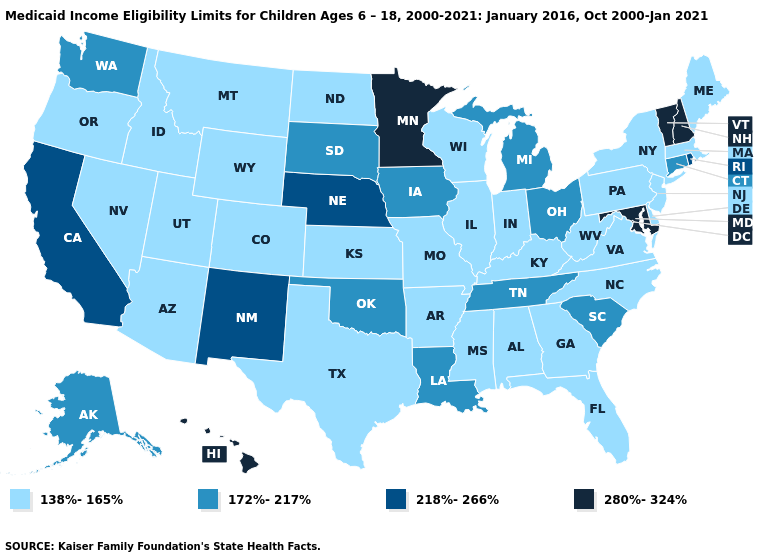Does Michigan have the same value as Vermont?
Answer briefly. No. Name the states that have a value in the range 280%-324%?
Concise answer only. Hawaii, Maryland, Minnesota, New Hampshire, Vermont. Among the states that border New Jersey , which have the lowest value?
Answer briefly. Delaware, New York, Pennsylvania. What is the value of Tennessee?
Quick response, please. 172%-217%. Among the states that border Connecticut , which have the highest value?
Concise answer only. Rhode Island. What is the highest value in states that border New Hampshire?
Answer briefly. 280%-324%. What is the value of West Virginia?
Keep it brief. 138%-165%. What is the value of Pennsylvania?
Answer briefly. 138%-165%. Name the states that have a value in the range 172%-217%?
Write a very short answer. Alaska, Connecticut, Iowa, Louisiana, Michigan, Ohio, Oklahoma, South Carolina, South Dakota, Tennessee, Washington. Does Georgia have a lower value than Pennsylvania?
Short answer required. No. What is the value of New Mexico?
Quick response, please. 218%-266%. Name the states that have a value in the range 280%-324%?
Be succinct. Hawaii, Maryland, Minnesota, New Hampshire, Vermont. Which states have the lowest value in the MidWest?
Give a very brief answer. Illinois, Indiana, Kansas, Missouri, North Dakota, Wisconsin. Among the states that border Louisiana , which have the highest value?
Give a very brief answer. Arkansas, Mississippi, Texas. What is the highest value in the USA?
Quick response, please. 280%-324%. 